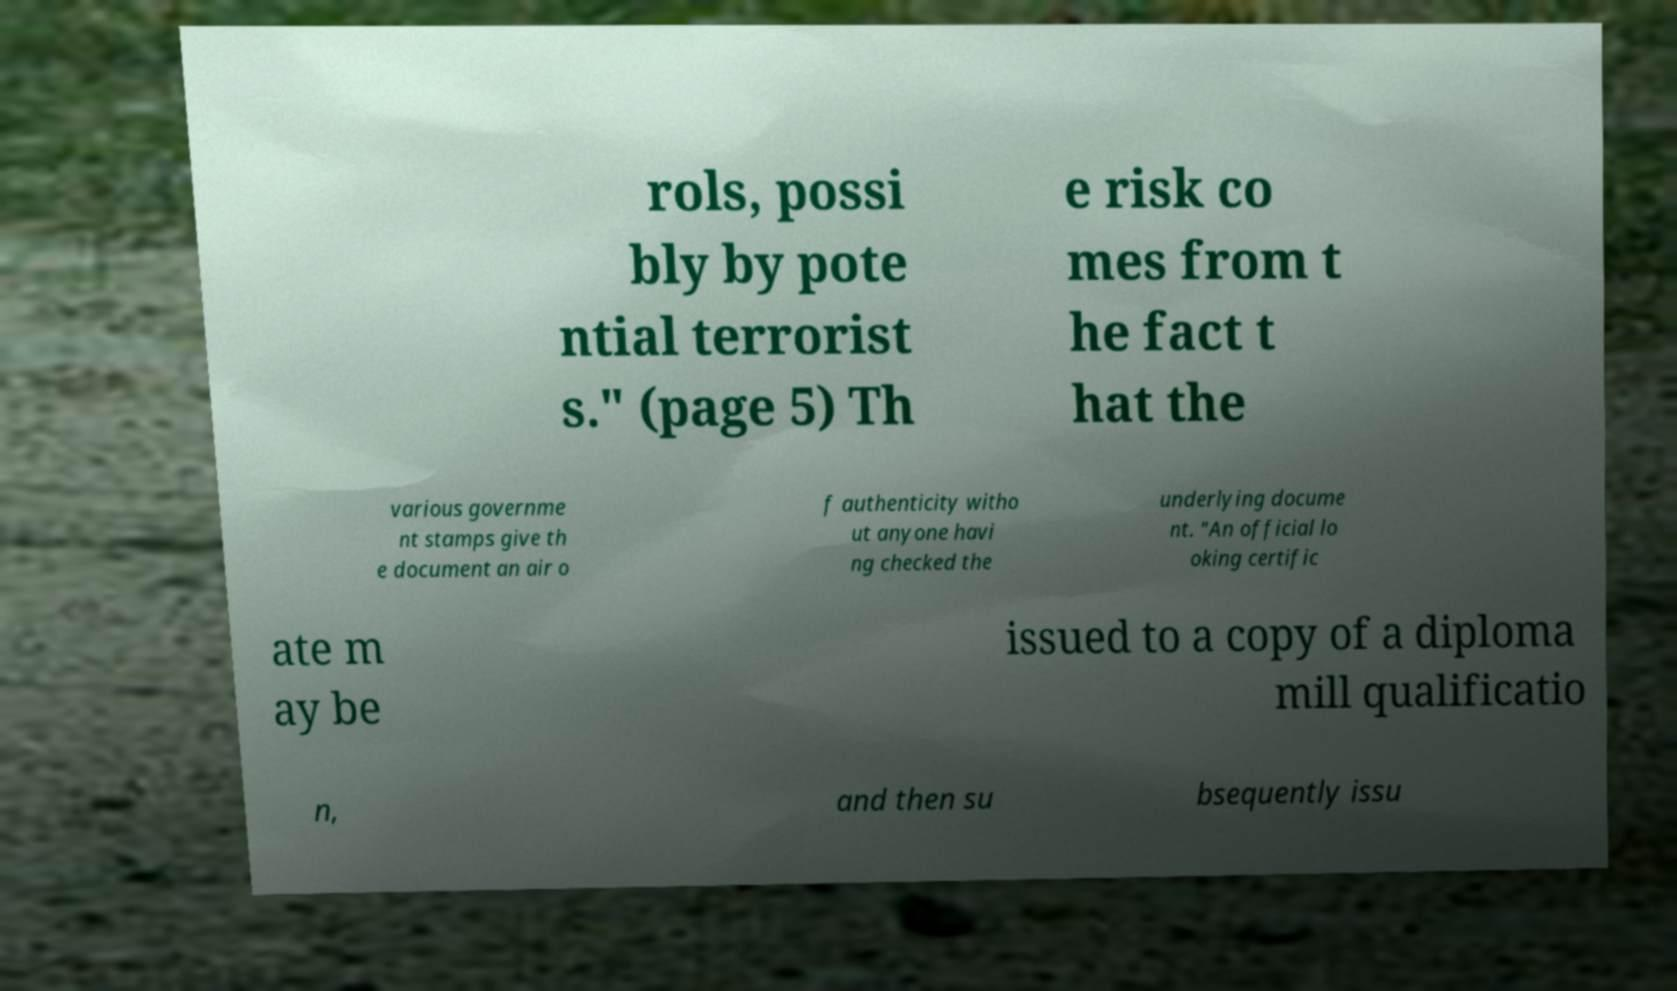There's text embedded in this image that I need extracted. Can you transcribe it verbatim? rols, possi bly by pote ntial terrorist s." (page 5) Th e risk co mes from t he fact t hat the various governme nt stamps give th e document an air o f authenticity witho ut anyone havi ng checked the underlying docume nt. "An official lo oking certific ate m ay be issued to a copy of a diploma mill qualificatio n, and then su bsequently issu 